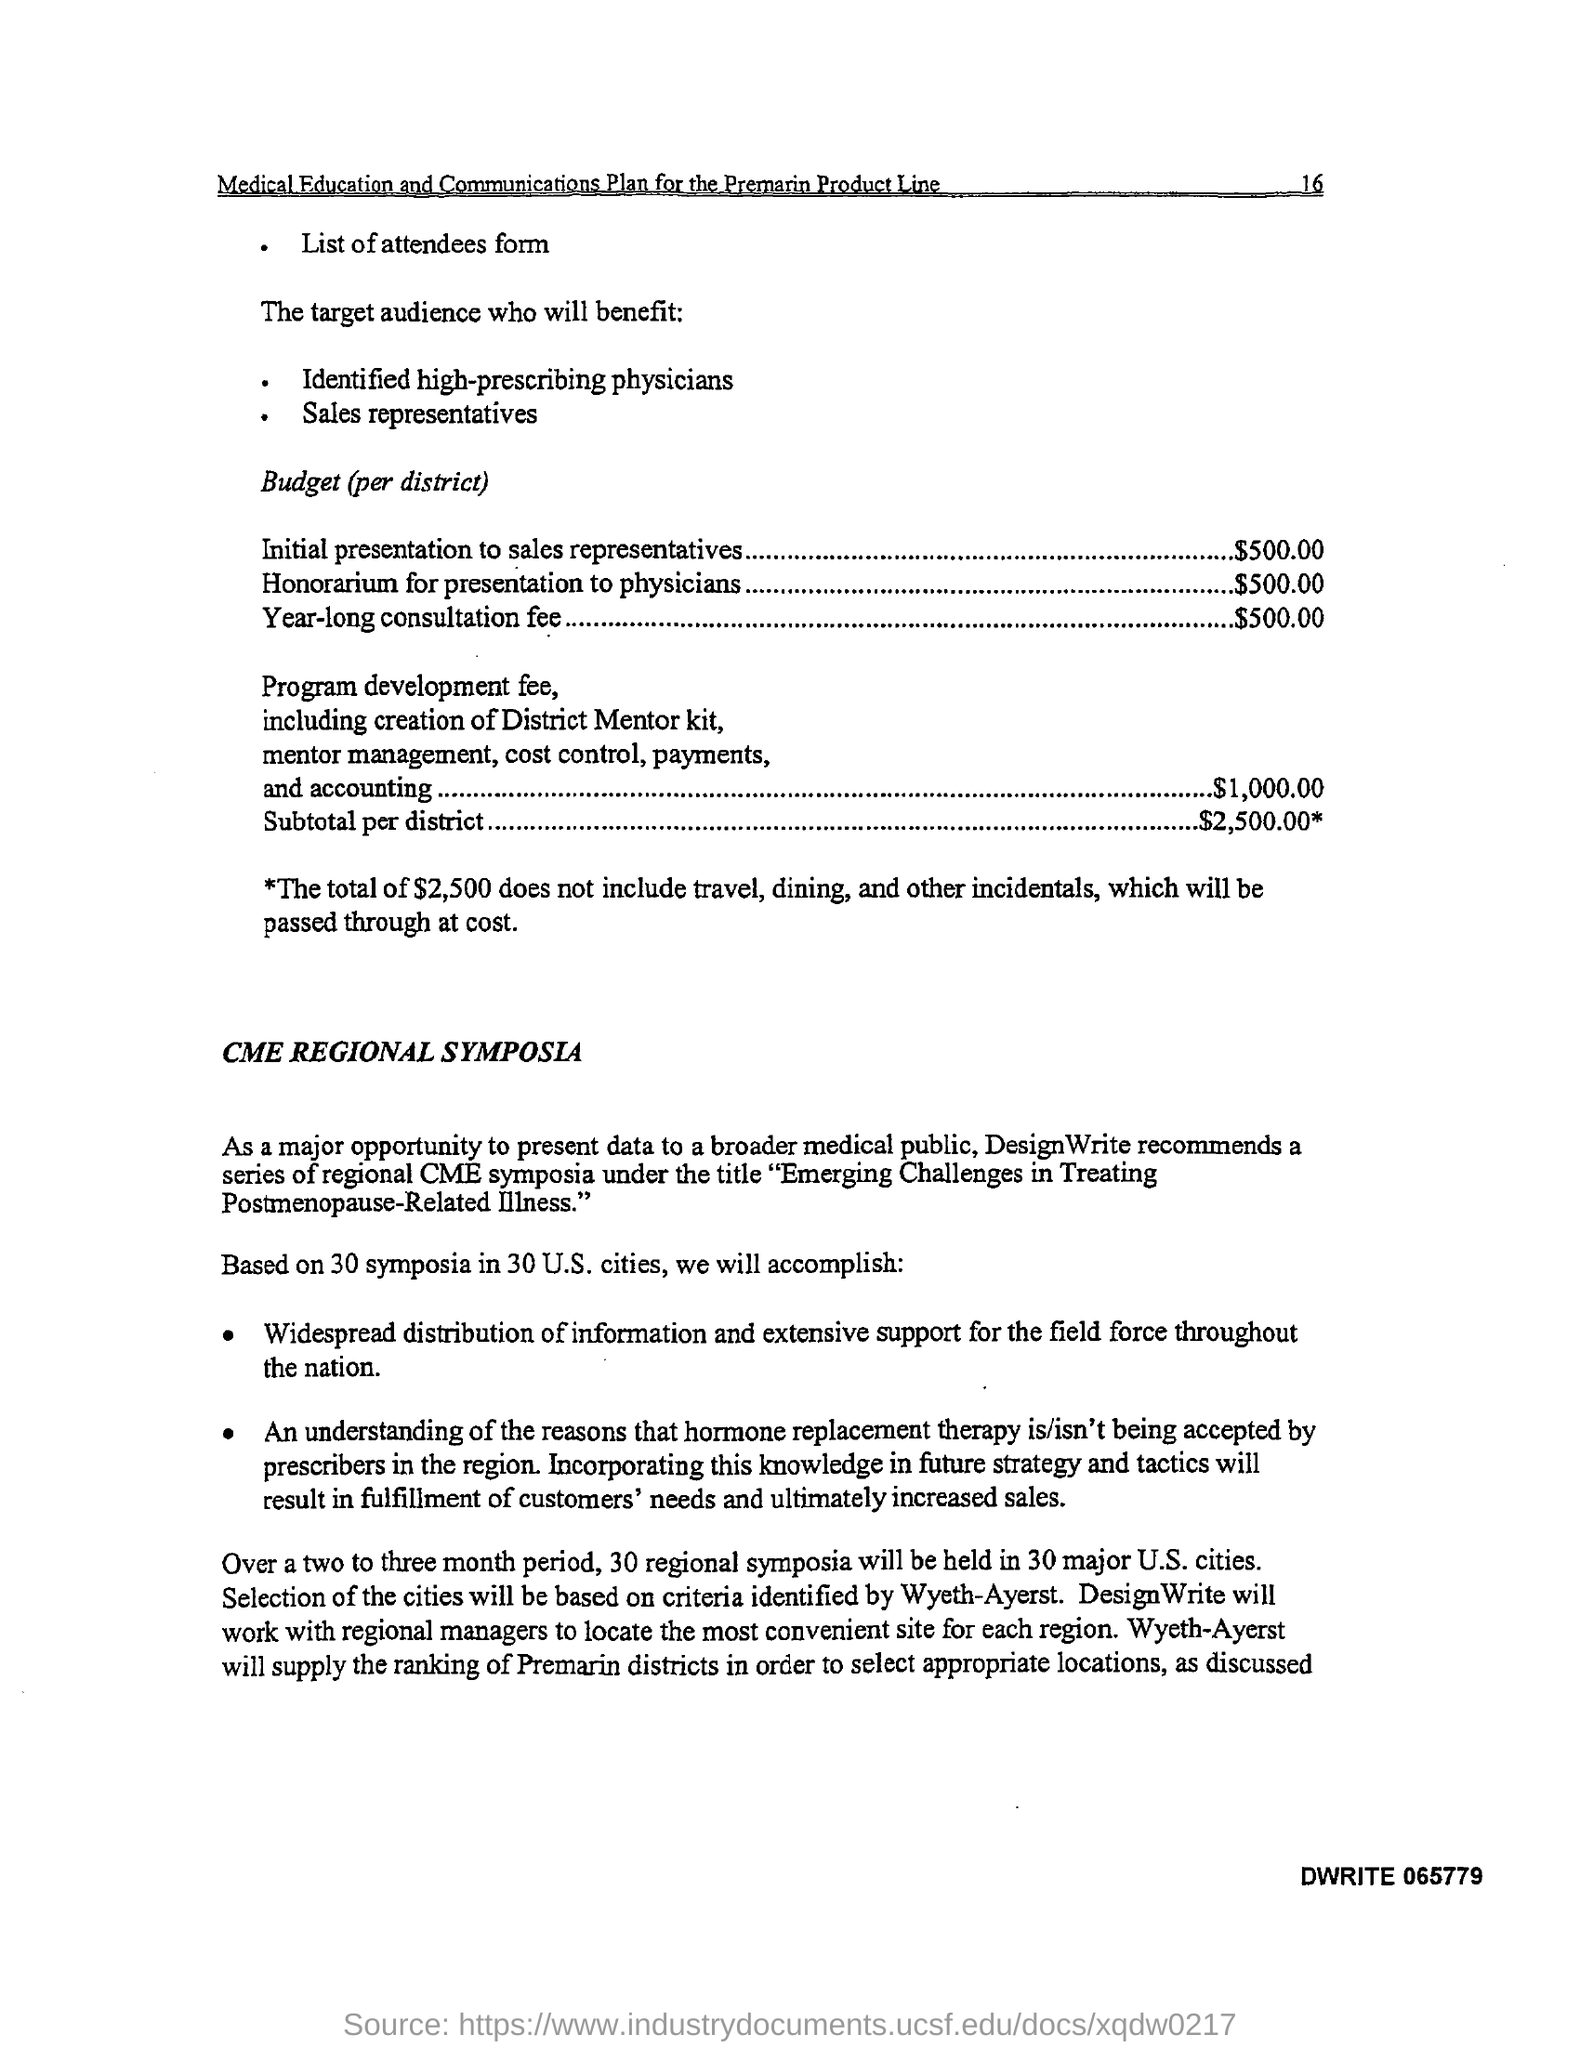Specify some key components in this picture. The honorarium for presentations to physicians per district is $500.00. The budget for a one-year consultation fee per district is $500.00. The budget for the initial presentation to sales representatives per district is $500.00. The total budget allocated for each district is $2,500.00. 